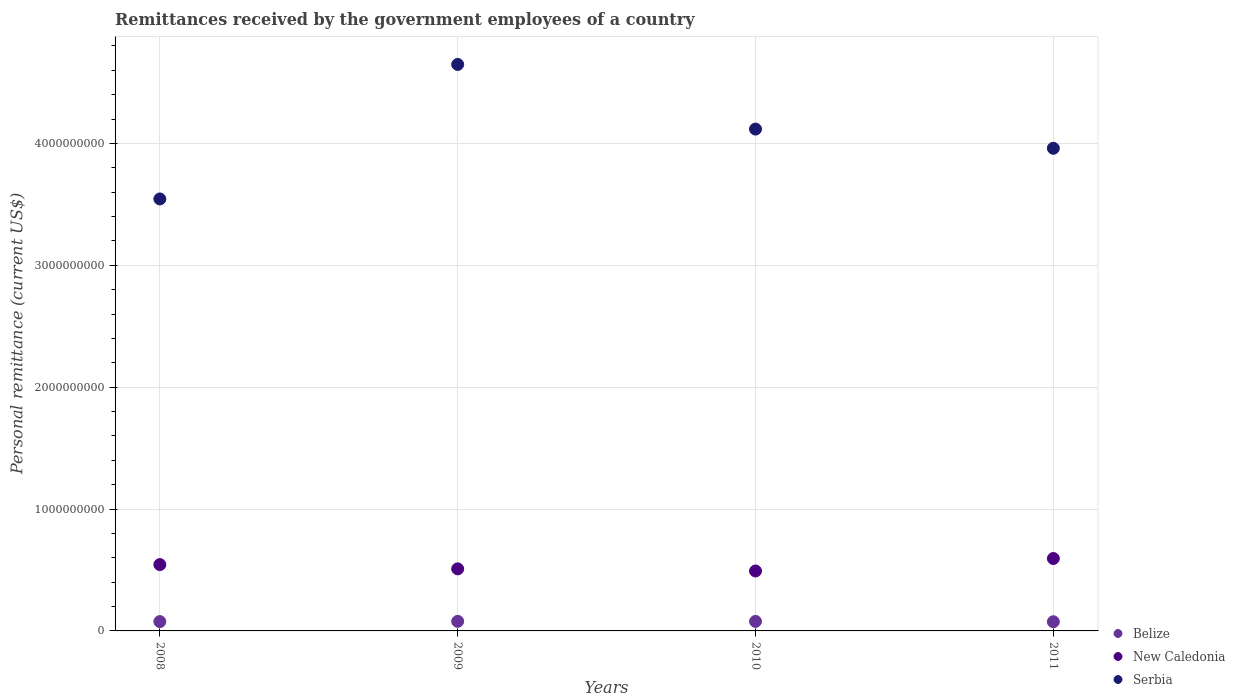What is the remittances received by the government employees in Belize in 2008?
Your response must be concise. 7.65e+07. Across all years, what is the maximum remittances received by the government employees in Serbia?
Provide a short and direct response. 4.65e+09. Across all years, what is the minimum remittances received by the government employees in Serbia?
Ensure brevity in your answer.  3.54e+09. In which year was the remittances received by the government employees in Serbia maximum?
Ensure brevity in your answer.  2009. In which year was the remittances received by the government employees in New Caledonia minimum?
Provide a succinct answer. 2010. What is the total remittances received by the government employees in Belize in the graph?
Your response must be concise. 3.09e+08. What is the difference between the remittances received by the government employees in Belize in 2009 and that in 2011?
Your response must be concise. 3.25e+06. What is the difference between the remittances received by the government employees in New Caledonia in 2009 and the remittances received by the government employees in Belize in 2008?
Give a very brief answer. 4.33e+08. What is the average remittances received by the government employees in New Caledonia per year?
Provide a short and direct response. 5.35e+08. In the year 2008, what is the difference between the remittances received by the government employees in Serbia and remittances received by the government employees in Belize?
Offer a terse response. 3.47e+09. What is the ratio of the remittances received by the government employees in New Caledonia in 2008 to that in 2010?
Make the answer very short. 1.11. Is the remittances received by the government employees in Serbia in 2010 less than that in 2011?
Make the answer very short. No. What is the difference between the highest and the second highest remittances received by the government employees in Belize?
Keep it short and to the point. 4.44e+05. What is the difference between the highest and the lowest remittances received by the government employees in Belize?
Offer a terse response. 3.25e+06. In how many years, is the remittances received by the government employees in Belize greater than the average remittances received by the government employees in Belize taken over all years?
Offer a very short reply. 2. Is the sum of the remittances received by the government employees in Belize in 2008 and 2011 greater than the maximum remittances received by the government employees in Serbia across all years?
Offer a terse response. No. Is it the case that in every year, the sum of the remittances received by the government employees in New Caledonia and remittances received by the government employees in Serbia  is greater than the remittances received by the government employees in Belize?
Make the answer very short. Yes. Is the remittances received by the government employees in New Caledonia strictly greater than the remittances received by the government employees in Serbia over the years?
Offer a terse response. No. Is the remittances received by the government employees in Belize strictly less than the remittances received by the government employees in New Caledonia over the years?
Ensure brevity in your answer.  Yes. What is the difference between two consecutive major ticks on the Y-axis?
Provide a short and direct response. 1.00e+09. Are the values on the major ticks of Y-axis written in scientific E-notation?
Offer a very short reply. No. Does the graph contain any zero values?
Your response must be concise. No. Does the graph contain grids?
Your answer should be very brief. Yes. How are the legend labels stacked?
Keep it short and to the point. Vertical. What is the title of the graph?
Give a very brief answer. Remittances received by the government employees of a country. Does "New Zealand" appear as one of the legend labels in the graph?
Make the answer very short. No. What is the label or title of the X-axis?
Your response must be concise. Years. What is the label or title of the Y-axis?
Provide a succinct answer. Personal remittance (current US$). What is the Personal remittance (current US$) of Belize in 2008?
Your response must be concise. 7.65e+07. What is the Personal remittance (current US$) in New Caledonia in 2008?
Make the answer very short. 5.44e+08. What is the Personal remittance (current US$) of Serbia in 2008?
Your answer should be compact. 3.54e+09. What is the Personal remittance (current US$) in Belize in 2009?
Your answer should be compact. 7.86e+07. What is the Personal remittance (current US$) in New Caledonia in 2009?
Give a very brief answer. 5.09e+08. What is the Personal remittance (current US$) of Serbia in 2009?
Ensure brevity in your answer.  4.65e+09. What is the Personal remittance (current US$) in Belize in 2010?
Give a very brief answer. 7.81e+07. What is the Personal remittance (current US$) of New Caledonia in 2010?
Provide a succinct answer. 4.92e+08. What is the Personal remittance (current US$) of Serbia in 2010?
Ensure brevity in your answer.  4.12e+09. What is the Personal remittance (current US$) in Belize in 2011?
Offer a very short reply. 7.53e+07. What is the Personal remittance (current US$) in New Caledonia in 2011?
Keep it short and to the point. 5.94e+08. What is the Personal remittance (current US$) in Serbia in 2011?
Provide a short and direct response. 3.96e+09. Across all years, what is the maximum Personal remittance (current US$) in Belize?
Offer a terse response. 7.86e+07. Across all years, what is the maximum Personal remittance (current US$) of New Caledonia?
Ensure brevity in your answer.  5.94e+08. Across all years, what is the maximum Personal remittance (current US$) in Serbia?
Keep it short and to the point. 4.65e+09. Across all years, what is the minimum Personal remittance (current US$) in Belize?
Your response must be concise. 7.53e+07. Across all years, what is the minimum Personal remittance (current US$) of New Caledonia?
Make the answer very short. 4.92e+08. Across all years, what is the minimum Personal remittance (current US$) in Serbia?
Provide a short and direct response. 3.54e+09. What is the total Personal remittance (current US$) of Belize in the graph?
Your answer should be very brief. 3.09e+08. What is the total Personal remittance (current US$) in New Caledonia in the graph?
Offer a very short reply. 2.14e+09. What is the total Personal remittance (current US$) in Serbia in the graph?
Keep it short and to the point. 1.63e+1. What is the difference between the Personal remittance (current US$) in Belize in 2008 and that in 2009?
Offer a very short reply. -2.09e+06. What is the difference between the Personal remittance (current US$) in New Caledonia in 2008 and that in 2009?
Keep it short and to the point. 3.49e+07. What is the difference between the Personal remittance (current US$) in Serbia in 2008 and that in 2009?
Your response must be concise. -1.10e+09. What is the difference between the Personal remittance (current US$) in Belize in 2008 and that in 2010?
Keep it short and to the point. -1.65e+06. What is the difference between the Personal remittance (current US$) in New Caledonia in 2008 and that in 2010?
Give a very brief answer. 5.24e+07. What is the difference between the Personal remittance (current US$) of Serbia in 2008 and that in 2010?
Your answer should be compact. -5.73e+08. What is the difference between the Personal remittance (current US$) of Belize in 2008 and that in 2011?
Offer a terse response. 1.17e+06. What is the difference between the Personal remittance (current US$) of New Caledonia in 2008 and that in 2011?
Your response must be concise. -5.00e+07. What is the difference between the Personal remittance (current US$) in Serbia in 2008 and that in 2011?
Offer a terse response. -4.16e+08. What is the difference between the Personal remittance (current US$) in Belize in 2009 and that in 2010?
Your response must be concise. 4.44e+05. What is the difference between the Personal remittance (current US$) of New Caledonia in 2009 and that in 2010?
Offer a very short reply. 1.75e+07. What is the difference between the Personal remittance (current US$) of Serbia in 2009 and that in 2010?
Offer a very short reply. 5.31e+08. What is the difference between the Personal remittance (current US$) of Belize in 2009 and that in 2011?
Provide a short and direct response. 3.25e+06. What is the difference between the Personal remittance (current US$) of New Caledonia in 2009 and that in 2011?
Offer a terse response. -8.49e+07. What is the difference between the Personal remittance (current US$) of Serbia in 2009 and that in 2011?
Your response must be concise. 6.88e+08. What is the difference between the Personal remittance (current US$) of Belize in 2010 and that in 2011?
Offer a terse response. 2.81e+06. What is the difference between the Personal remittance (current US$) in New Caledonia in 2010 and that in 2011?
Keep it short and to the point. -1.02e+08. What is the difference between the Personal remittance (current US$) in Serbia in 2010 and that in 2011?
Ensure brevity in your answer.  1.57e+08. What is the difference between the Personal remittance (current US$) of Belize in 2008 and the Personal remittance (current US$) of New Caledonia in 2009?
Your answer should be compact. -4.33e+08. What is the difference between the Personal remittance (current US$) of Belize in 2008 and the Personal remittance (current US$) of Serbia in 2009?
Keep it short and to the point. -4.57e+09. What is the difference between the Personal remittance (current US$) in New Caledonia in 2008 and the Personal remittance (current US$) in Serbia in 2009?
Offer a very short reply. -4.10e+09. What is the difference between the Personal remittance (current US$) in Belize in 2008 and the Personal remittance (current US$) in New Caledonia in 2010?
Provide a succinct answer. -4.15e+08. What is the difference between the Personal remittance (current US$) of Belize in 2008 and the Personal remittance (current US$) of Serbia in 2010?
Ensure brevity in your answer.  -4.04e+09. What is the difference between the Personal remittance (current US$) in New Caledonia in 2008 and the Personal remittance (current US$) in Serbia in 2010?
Ensure brevity in your answer.  -3.57e+09. What is the difference between the Personal remittance (current US$) in Belize in 2008 and the Personal remittance (current US$) in New Caledonia in 2011?
Make the answer very short. -5.18e+08. What is the difference between the Personal remittance (current US$) in Belize in 2008 and the Personal remittance (current US$) in Serbia in 2011?
Your response must be concise. -3.88e+09. What is the difference between the Personal remittance (current US$) in New Caledonia in 2008 and the Personal remittance (current US$) in Serbia in 2011?
Your answer should be compact. -3.42e+09. What is the difference between the Personal remittance (current US$) of Belize in 2009 and the Personal remittance (current US$) of New Caledonia in 2010?
Offer a very short reply. -4.13e+08. What is the difference between the Personal remittance (current US$) of Belize in 2009 and the Personal remittance (current US$) of Serbia in 2010?
Provide a succinct answer. -4.04e+09. What is the difference between the Personal remittance (current US$) in New Caledonia in 2009 and the Personal remittance (current US$) in Serbia in 2010?
Your answer should be very brief. -3.61e+09. What is the difference between the Personal remittance (current US$) in Belize in 2009 and the Personal remittance (current US$) in New Caledonia in 2011?
Give a very brief answer. -5.16e+08. What is the difference between the Personal remittance (current US$) of Belize in 2009 and the Personal remittance (current US$) of Serbia in 2011?
Provide a short and direct response. -3.88e+09. What is the difference between the Personal remittance (current US$) of New Caledonia in 2009 and the Personal remittance (current US$) of Serbia in 2011?
Offer a terse response. -3.45e+09. What is the difference between the Personal remittance (current US$) in Belize in 2010 and the Personal remittance (current US$) in New Caledonia in 2011?
Your answer should be compact. -5.16e+08. What is the difference between the Personal remittance (current US$) in Belize in 2010 and the Personal remittance (current US$) in Serbia in 2011?
Offer a very short reply. -3.88e+09. What is the difference between the Personal remittance (current US$) of New Caledonia in 2010 and the Personal remittance (current US$) of Serbia in 2011?
Provide a succinct answer. -3.47e+09. What is the average Personal remittance (current US$) in Belize per year?
Your answer should be compact. 7.71e+07. What is the average Personal remittance (current US$) of New Caledonia per year?
Offer a very short reply. 5.35e+08. What is the average Personal remittance (current US$) in Serbia per year?
Provide a succinct answer. 4.07e+09. In the year 2008, what is the difference between the Personal remittance (current US$) of Belize and Personal remittance (current US$) of New Caledonia?
Ensure brevity in your answer.  -4.68e+08. In the year 2008, what is the difference between the Personal remittance (current US$) in Belize and Personal remittance (current US$) in Serbia?
Give a very brief answer. -3.47e+09. In the year 2008, what is the difference between the Personal remittance (current US$) of New Caledonia and Personal remittance (current US$) of Serbia?
Your response must be concise. -3.00e+09. In the year 2009, what is the difference between the Personal remittance (current US$) in Belize and Personal remittance (current US$) in New Caledonia?
Provide a short and direct response. -4.31e+08. In the year 2009, what is the difference between the Personal remittance (current US$) in Belize and Personal remittance (current US$) in Serbia?
Give a very brief answer. -4.57e+09. In the year 2009, what is the difference between the Personal remittance (current US$) in New Caledonia and Personal remittance (current US$) in Serbia?
Your answer should be compact. -4.14e+09. In the year 2010, what is the difference between the Personal remittance (current US$) of Belize and Personal remittance (current US$) of New Caledonia?
Offer a very short reply. -4.14e+08. In the year 2010, what is the difference between the Personal remittance (current US$) in Belize and Personal remittance (current US$) in Serbia?
Offer a very short reply. -4.04e+09. In the year 2010, what is the difference between the Personal remittance (current US$) of New Caledonia and Personal remittance (current US$) of Serbia?
Your answer should be compact. -3.63e+09. In the year 2011, what is the difference between the Personal remittance (current US$) of Belize and Personal remittance (current US$) of New Caledonia?
Provide a short and direct response. -5.19e+08. In the year 2011, what is the difference between the Personal remittance (current US$) in Belize and Personal remittance (current US$) in Serbia?
Your answer should be compact. -3.88e+09. In the year 2011, what is the difference between the Personal remittance (current US$) in New Caledonia and Personal remittance (current US$) in Serbia?
Offer a very short reply. -3.37e+09. What is the ratio of the Personal remittance (current US$) of Belize in 2008 to that in 2009?
Provide a short and direct response. 0.97. What is the ratio of the Personal remittance (current US$) of New Caledonia in 2008 to that in 2009?
Provide a short and direct response. 1.07. What is the ratio of the Personal remittance (current US$) of Serbia in 2008 to that in 2009?
Your answer should be compact. 0.76. What is the ratio of the Personal remittance (current US$) in Belize in 2008 to that in 2010?
Offer a terse response. 0.98. What is the ratio of the Personal remittance (current US$) in New Caledonia in 2008 to that in 2010?
Provide a short and direct response. 1.11. What is the ratio of the Personal remittance (current US$) of Serbia in 2008 to that in 2010?
Offer a very short reply. 0.86. What is the ratio of the Personal remittance (current US$) in Belize in 2008 to that in 2011?
Your response must be concise. 1.02. What is the ratio of the Personal remittance (current US$) of New Caledonia in 2008 to that in 2011?
Keep it short and to the point. 0.92. What is the ratio of the Personal remittance (current US$) in Serbia in 2008 to that in 2011?
Your response must be concise. 0.9. What is the ratio of the Personal remittance (current US$) in New Caledonia in 2009 to that in 2010?
Ensure brevity in your answer.  1.04. What is the ratio of the Personal remittance (current US$) of Serbia in 2009 to that in 2010?
Keep it short and to the point. 1.13. What is the ratio of the Personal remittance (current US$) of Belize in 2009 to that in 2011?
Keep it short and to the point. 1.04. What is the ratio of the Personal remittance (current US$) in Serbia in 2009 to that in 2011?
Give a very brief answer. 1.17. What is the ratio of the Personal remittance (current US$) in Belize in 2010 to that in 2011?
Offer a terse response. 1.04. What is the ratio of the Personal remittance (current US$) in New Caledonia in 2010 to that in 2011?
Your answer should be very brief. 0.83. What is the ratio of the Personal remittance (current US$) in Serbia in 2010 to that in 2011?
Provide a short and direct response. 1.04. What is the difference between the highest and the second highest Personal remittance (current US$) in Belize?
Your answer should be compact. 4.44e+05. What is the difference between the highest and the second highest Personal remittance (current US$) in New Caledonia?
Offer a very short reply. 5.00e+07. What is the difference between the highest and the second highest Personal remittance (current US$) of Serbia?
Your answer should be very brief. 5.31e+08. What is the difference between the highest and the lowest Personal remittance (current US$) in Belize?
Make the answer very short. 3.25e+06. What is the difference between the highest and the lowest Personal remittance (current US$) of New Caledonia?
Provide a short and direct response. 1.02e+08. What is the difference between the highest and the lowest Personal remittance (current US$) in Serbia?
Make the answer very short. 1.10e+09. 